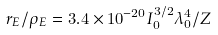<formula> <loc_0><loc_0><loc_500><loc_500>r _ { E } / \rho _ { E } = 3 . 4 \times 1 0 ^ { - 2 0 } I _ { 0 } ^ { 3 / 2 } \lambda _ { 0 } ^ { 4 } / Z</formula> 